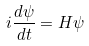Convert formula to latex. <formula><loc_0><loc_0><loc_500><loc_500>i \frac { d \psi } { d t } = { H } \psi</formula> 